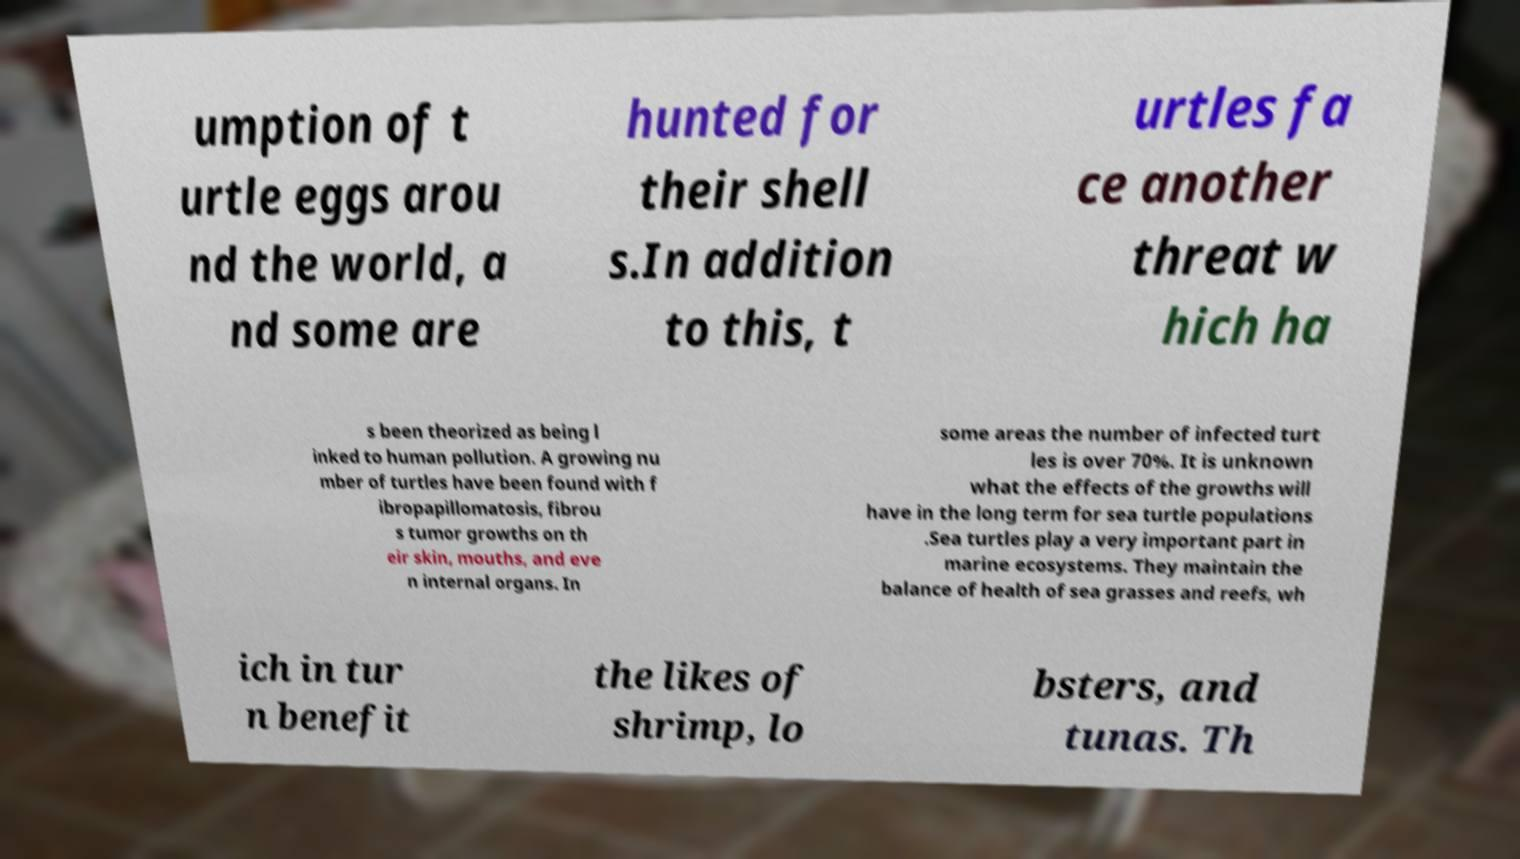Can you read and provide the text displayed in the image?This photo seems to have some interesting text. Can you extract and type it out for me? umption of t urtle eggs arou nd the world, a nd some are hunted for their shell s.In addition to this, t urtles fa ce another threat w hich ha s been theorized as being l inked to human pollution. A growing nu mber of turtles have been found with f ibropapillomatosis, fibrou s tumor growths on th eir skin, mouths, and eve n internal organs. In some areas the number of infected turt les is over 70%. It is unknown what the effects of the growths will have in the long term for sea turtle populations .Sea turtles play a very important part in marine ecosystems. They maintain the balance of health of sea grasses and reefs, wh ich in tur n benefit the likes of shrimp, lo bsters, and tunas. Th 